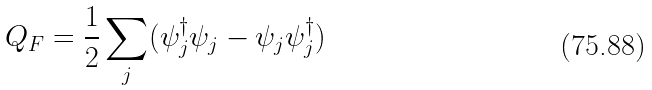<formula> <loc_0><loc_0><loc_500><loc_500>Q _ { F } = \frac { 1 } { 2 } \sum _ { j } ( \psi _ { j } ^ { \dagger } \psi _ { j } - \psi _ { j } \psi ^ { \dagger } _ { j } )</formula> 